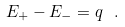Convert formula to latex. <formula><loc_0><loc_0><loc_500><loc_500>E _ { + } - E _ { - } = q \ .</formula> 